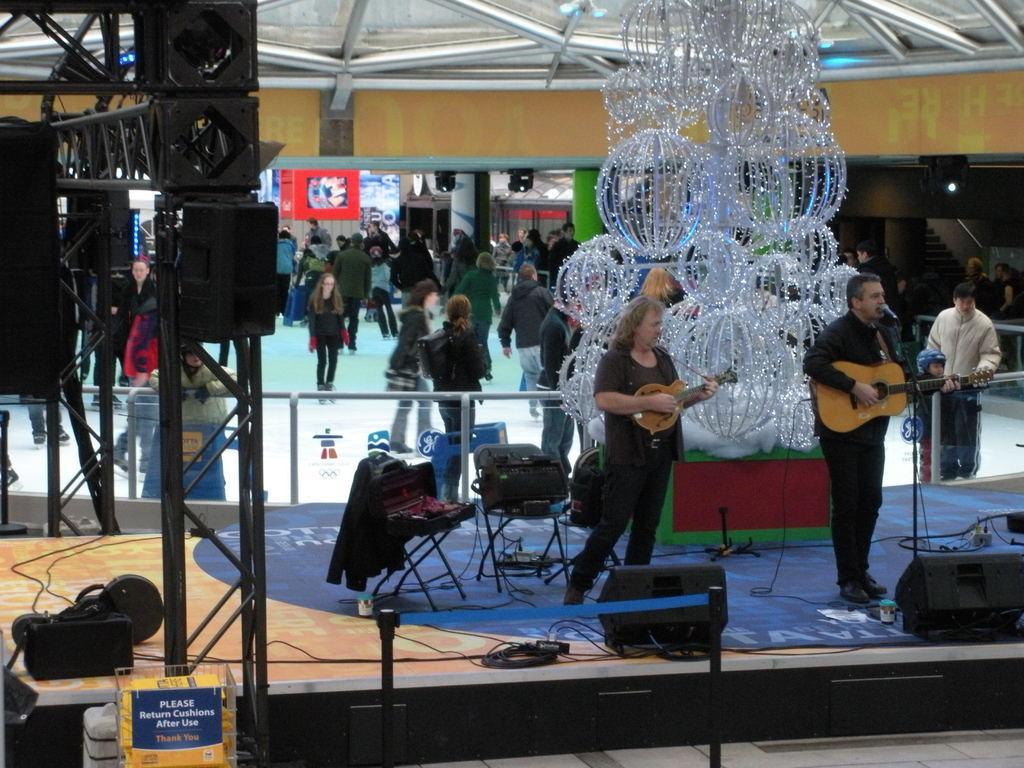Could you give a brief overview of what you see in this image? In this image there are two people singing while playing the guitar inside a mall, behind them there are a few people walking. 